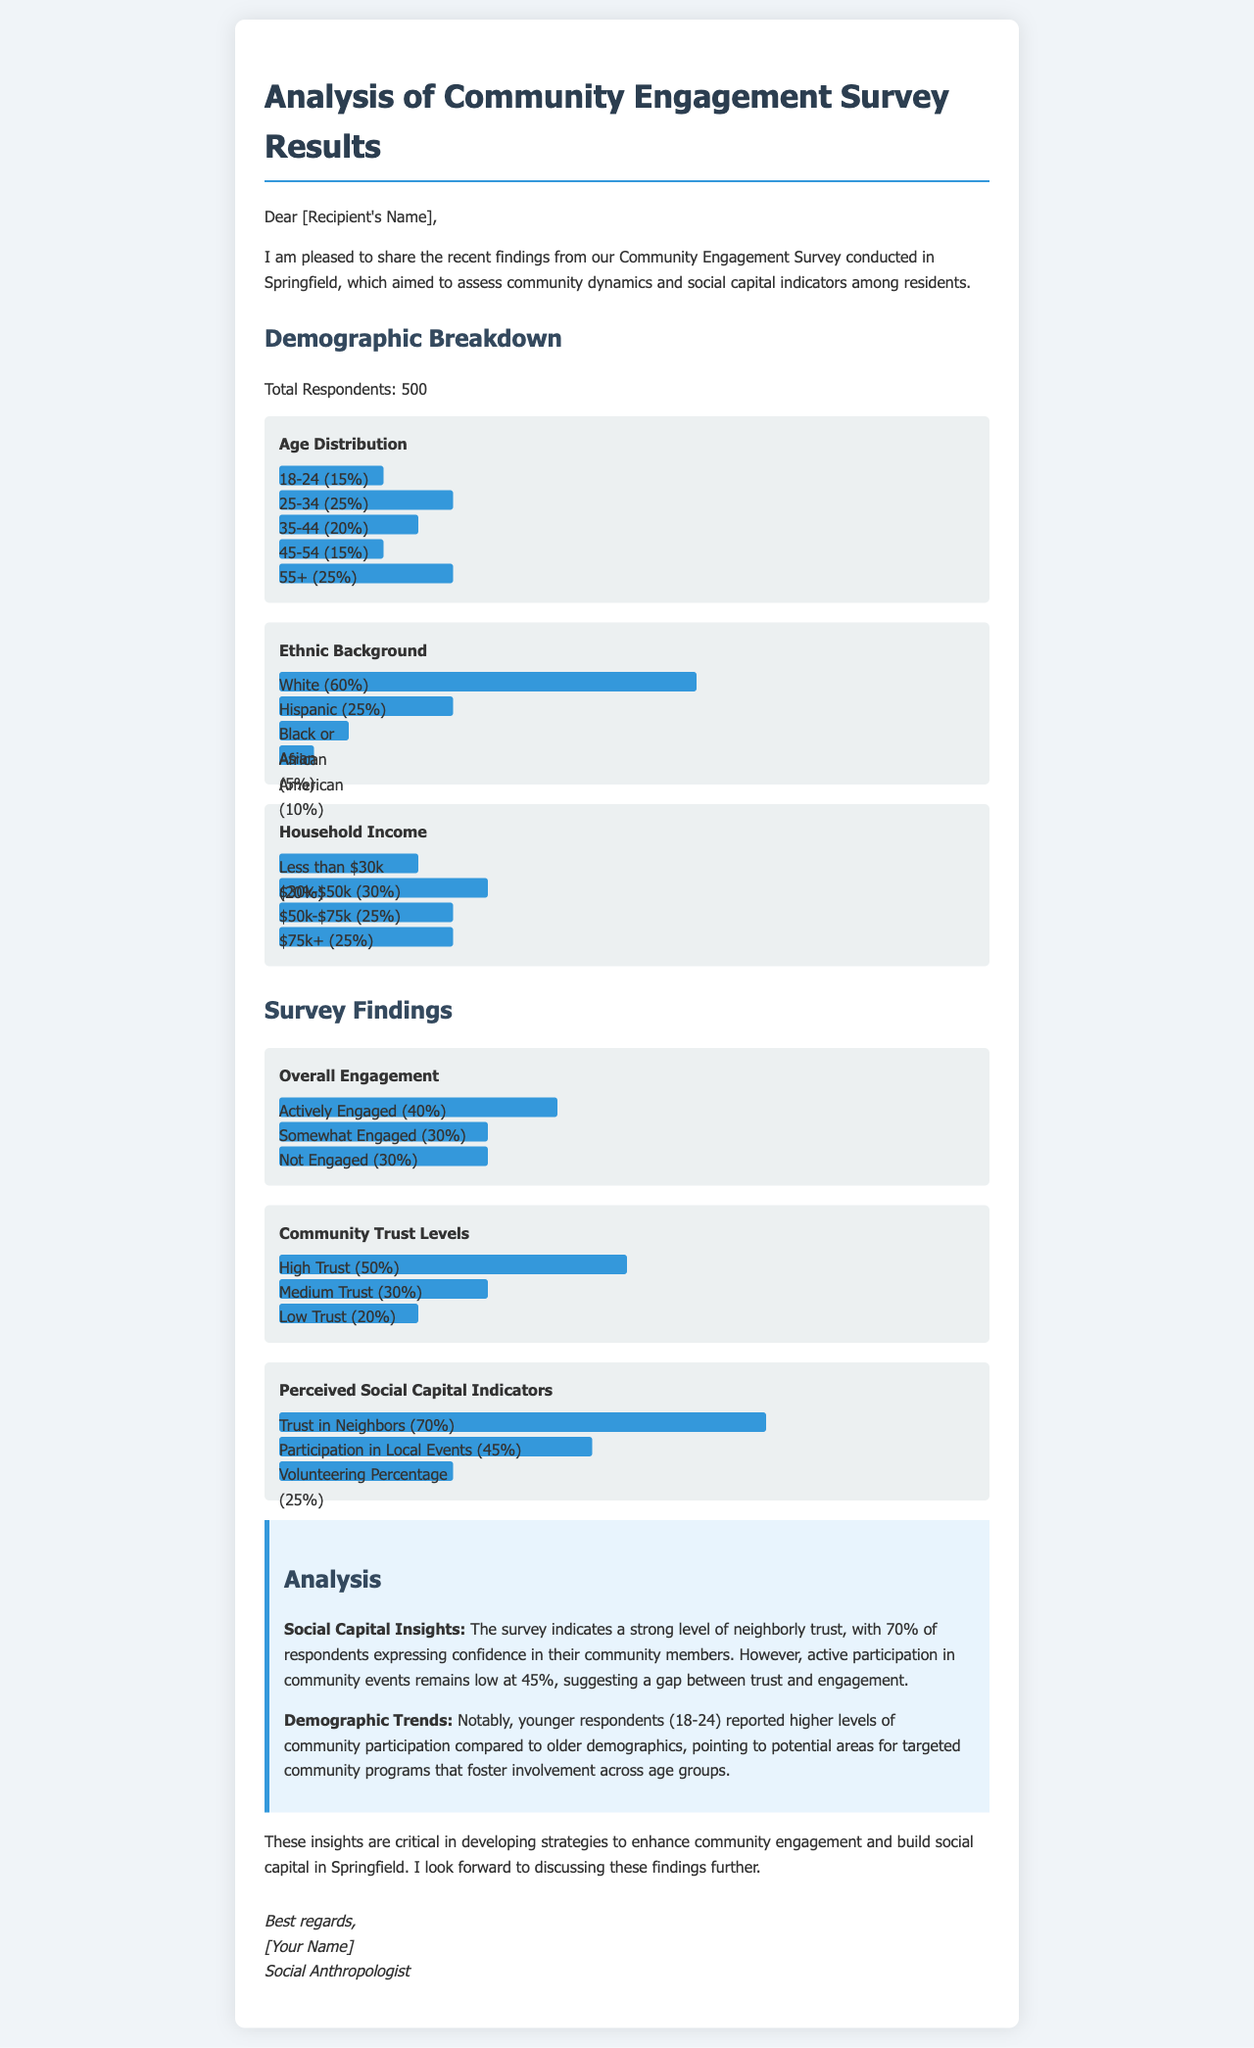What was the total number of respondents to the survey? The total respondents to the survey is mentioned directly in the document as 500.
Answer: 500 What percentage of respondents are in the 25-34 age group? The percentage for the 25-34 age group is explicitly shown in the age distribution section of the document.
Answer: 25% What is the highest reported ethnic background among respondents? The ethnic background with the highest percentage listed is "White," as shown in the ethnic background section.
Answer: White What percentage of respondents have high trust in their community? The document states that 50% of respondents reported high trust levels in the community.
Answer: 50% What social capital indicator has the highest reported percentage? The document indicates that "Trust in Neighbors" has the highest percentage reported among social capital indicators.
Answer: Trust in Neighbors How many respondents are actively engaged in the community? The document specifies that 40% of respondents are actively engaged.
Answer: 40% Which demographic group reported higher levels of community participation? The document indicates that younger respondents (18-24) showed higher participation levels compared to older groups.
Answer: Younger respondents What is the main insight regarding trust and engagement? The analysis highlights a gap between neighborly trust and active community engagement.
Answer: Trust and engagement gap What type of document is this? The structure and content indicate that this is an analysis report email regarding community engagement survey results.
Answer: Email report 